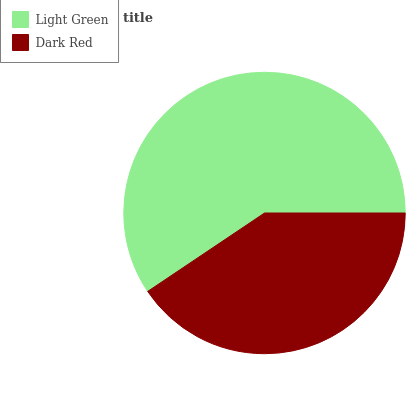Is Dark Red the minimum?
Answer yes or no. Yes. Is Light Green the maximum?
Answer yes or no. Yes. Is Dark Red the maximum?
Answer yes or no. No. Is Light Green greater than Dark Red?
Answer yes or no. Yes. Is Dark Red less than Light Green?
Answer yes or no. Yes. Is Dark Red greater than Light Green?
Answer yes or no. No. Is Light Green less than Dark Red?
Answer yes or no. No. Is Light Green the high median?
Answer yes or no. Yes. Is Dark Red the low median?
Answer yes or no. Yes. Is Dark Red the high median?
Answer yes or no. No. Is Light Green the low median?
Answer yes or no. No. 